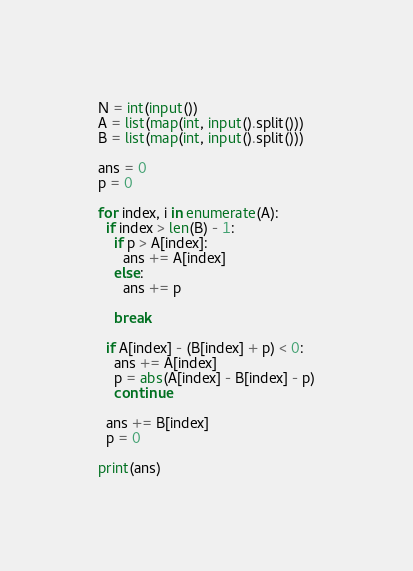<code> <loc_0><loc_0><loc_500><loc_500><_Python_>N = int(input())
A = list(map(int, input().split()))
B = list(map(int, input().split()))

ans = 0
p = 0

for index, i in enumerate(A):
  if index > len(B) - 1:
    if p > A[index]:
      ans += A[index]
    else:
      ans += p
      
    break

  if A[index] - (B[index] + p) < 0:
    ans += A[index]
    p = abs(A[index] - B[index] - p)
    continue

  ans += B[index]
  p = 0

print(ans)</code> 